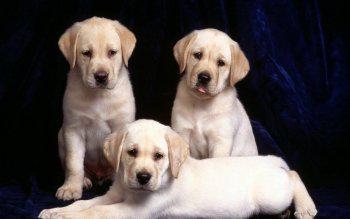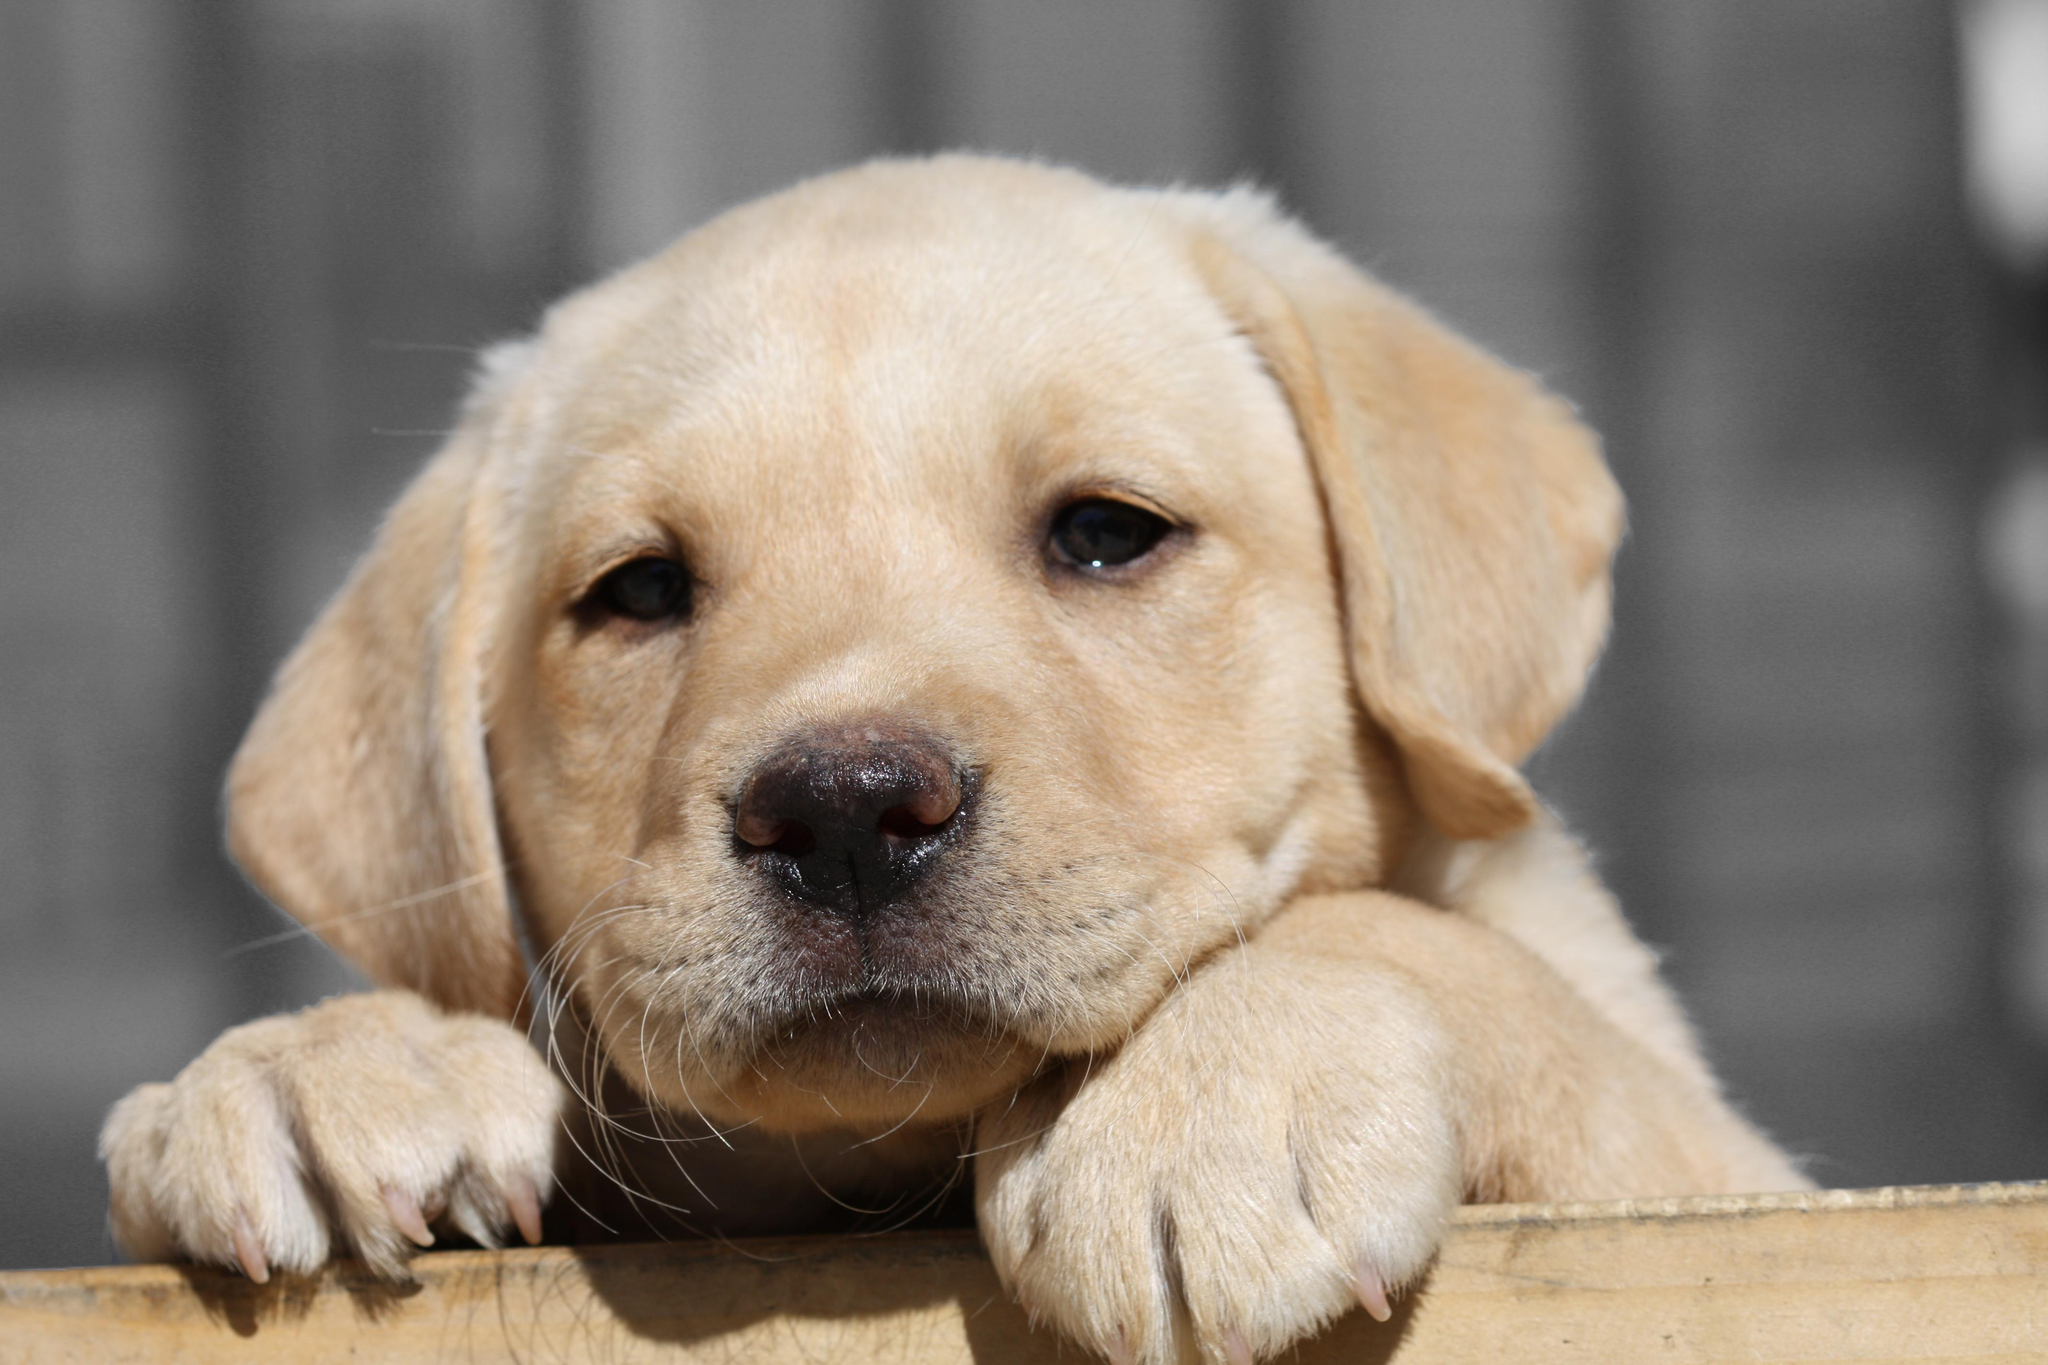The first image is the image on the left, the second image is the image on the right. Given the left and right images, does the statement "In one image, a puppy is leaning over a wooden ledge with only its head and front paws visible." hold true? Answer yes or no. Yes. The first image is the image on the left, the second image is the image on the right. Evaluate the accuracy of this statement regarding the images: "In 1 of the images, 1 dog is leaning over the edge of a wooden box.". Is it true? Answer yes or no. Yes. 